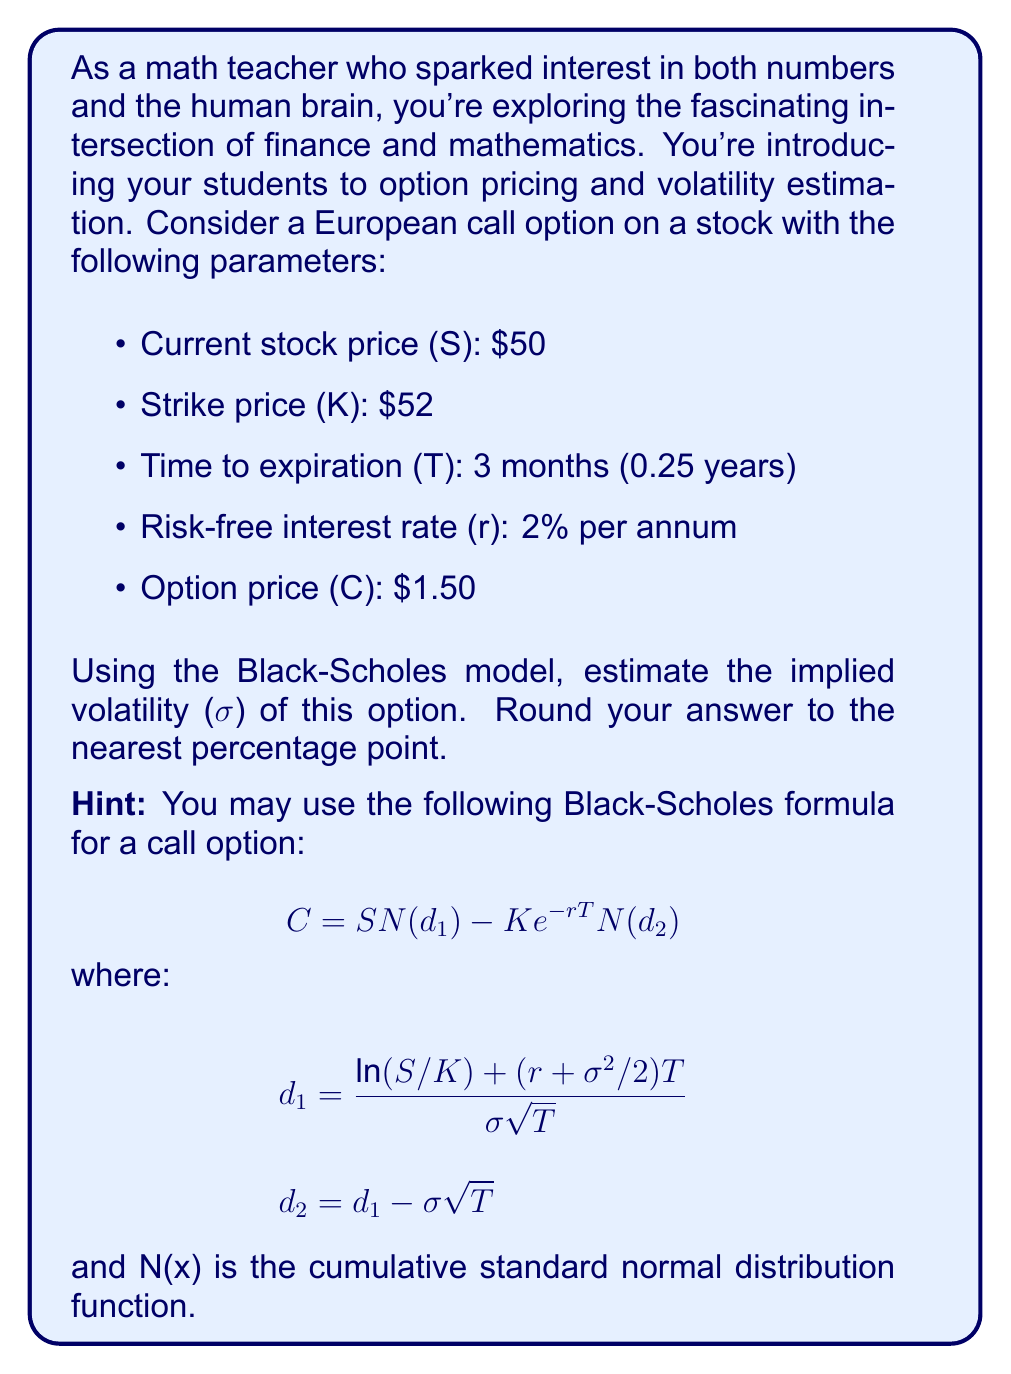Could you help me with this problem? To estimate the implied volatility, we need to use an iterative method since the Black-Scholes formula cannot be directly solved for σ. We'll use the bisection method:

1) Set an initial range for σ, say [0, 1].

2) Calculate the option price using the midpoint of the range.

3) If the calculated price is higher than the market price, the upper bound becomes the midpoint. If it's lower, the lower bound becomes the midpoint.

4) Repeat until the difference between calculated and market price is small enough.

Let's implement this:

Initial range: [0, 1]

Iteration 1:
σ = 0.5
C = $1.8924 (using Black-Scholes)
Too high, so new range: [0, 0.5]

Iteration 2:
σ = 0.25
C = $0.6813
Too low, so new range: [0.25, 0.5]

Iteration 3:
σ = 0.375
C = $1.2591
Too low, so new range: [0.375, 0.5]

Iteration 4:
σ = 0.4375
C = $1.5702
Too high, so new range: [0.375, 0.4375]

Iteration 5:
σ = 0.40625
C = $1.4129
Too low, so new range: [0.40625, 0.4375]

After a few more iterations, we converge to σ ≈ 0.4215 or 42.15%.

Rounding to the nearest percentage point gives us 42%.
Answer: 42% 